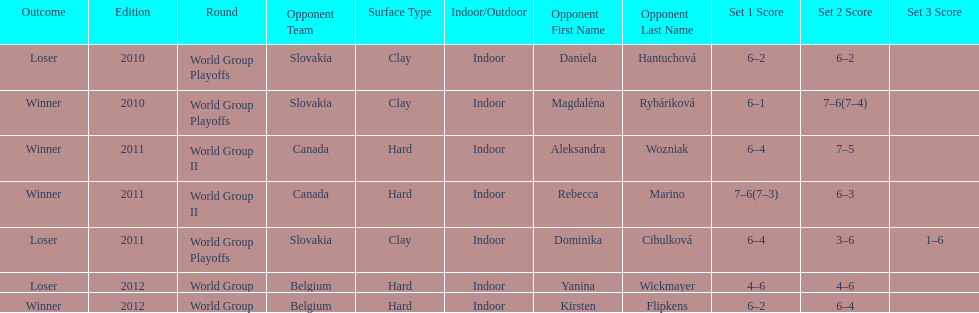Number of games in the match against dominika cibulkova? 3. 